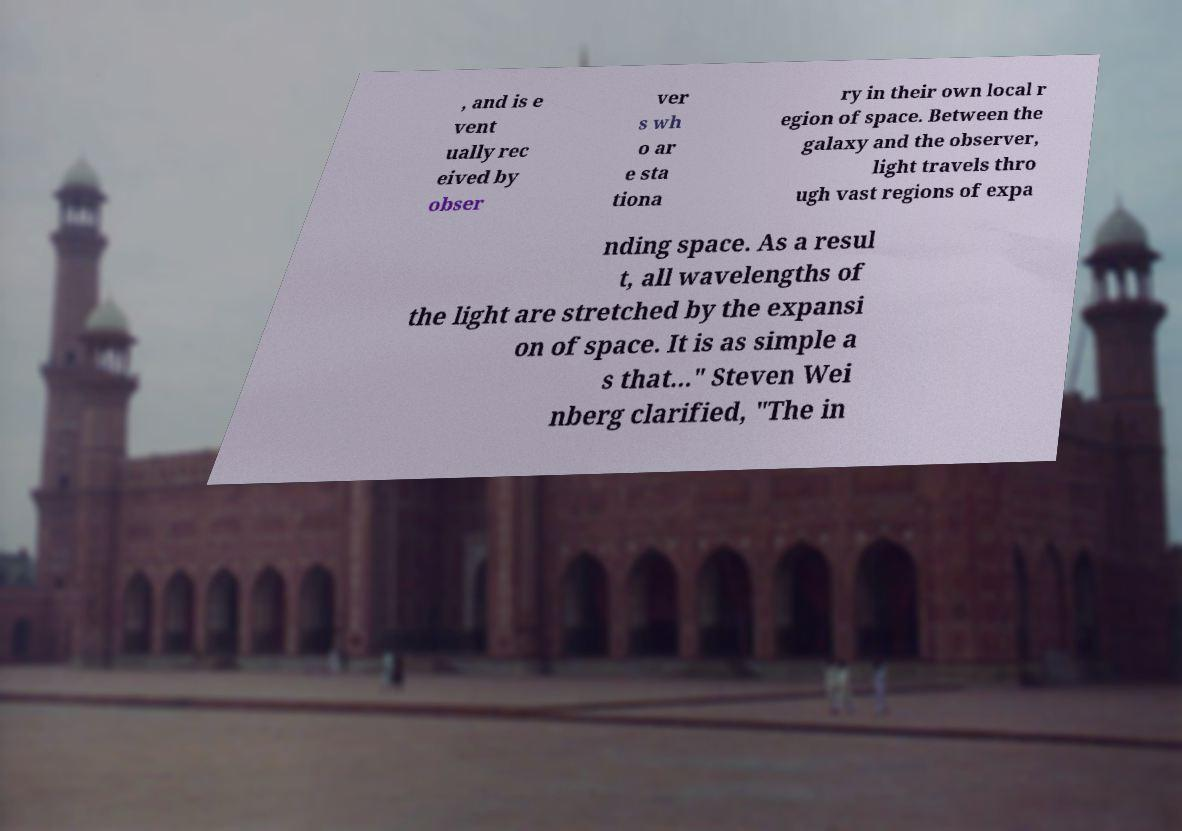Can you read and provide the text displayed in the image?This photo seems to have some interesting text. Can you extract and type it out for me? , and is e vent ually rec eived by obser ver s wh o ar e sta tiona ry in their own local r egion of space. Between the galaxy and the observer, light travels thro ugh vast regions of expa nding space. As a resul t, all wavelengths of the light are stretched by the expansi on of space. It is as simple a s that..." Steven Wei nberg clarified, "The in 